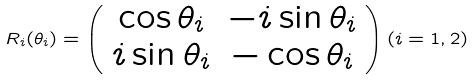Convert formula to latex. <formula><loc_0><loc_0><loc_500><loc_500>R _ { i } ( \theta _ { i } ) = \left ( \begin{array} { c c } \cos \theta _ { i } & - i \sin \theta _ { i } \\ i \sin \theta _ { i } & - \cos \theta _ { i } \end{array} \right ) ( i = 1 , 2 )</formula> 